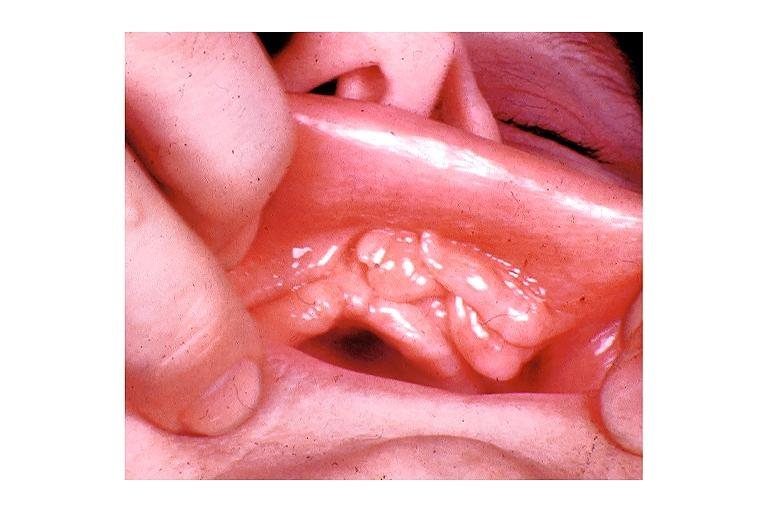what is present?
Answer the question using a single word or phrase. Oral 